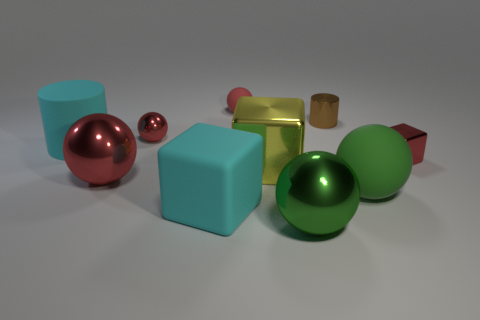What size is the cyan matte thing that is behind the red thing that is to the right of the red matte thing?
Your response must be concise. Large. Is there a large matte object of the same color as the matte cube?
Keep it short and to the point. Yes. There is a large metallic sphere that is on the left side of the tiny red metal ball; is it the same color as the large shiny ball that is right of the large cyan rubber cube?
Give a very brief answer. No. There is a green rubber thing; what shape is it?
Make the answer very short. Sphere. There is a large yellow block; what number of tiny blocks are in front of it?
Offer a terse response. 0. How many big green things are the same material as the small cylinder?
Keep it short and to the point. 1. Are the small cylinder behind the big yellow metallic object and the big red thing made of the same material?
Your answer should be very brief. Yes. Is there a red cube?
Ensure brevity in your answer.  Yes. There is a red shiny thing that is in front of the big cyan cylinder and left of the small red metal block; what is its size?
Ensure brevity in your answer.  Large. Is the number of big rubber blocks that are to the left of the large red ball greater than the number of red shiny spheres that are behind the yellow shiny thing?
Your response must be concise. No. 